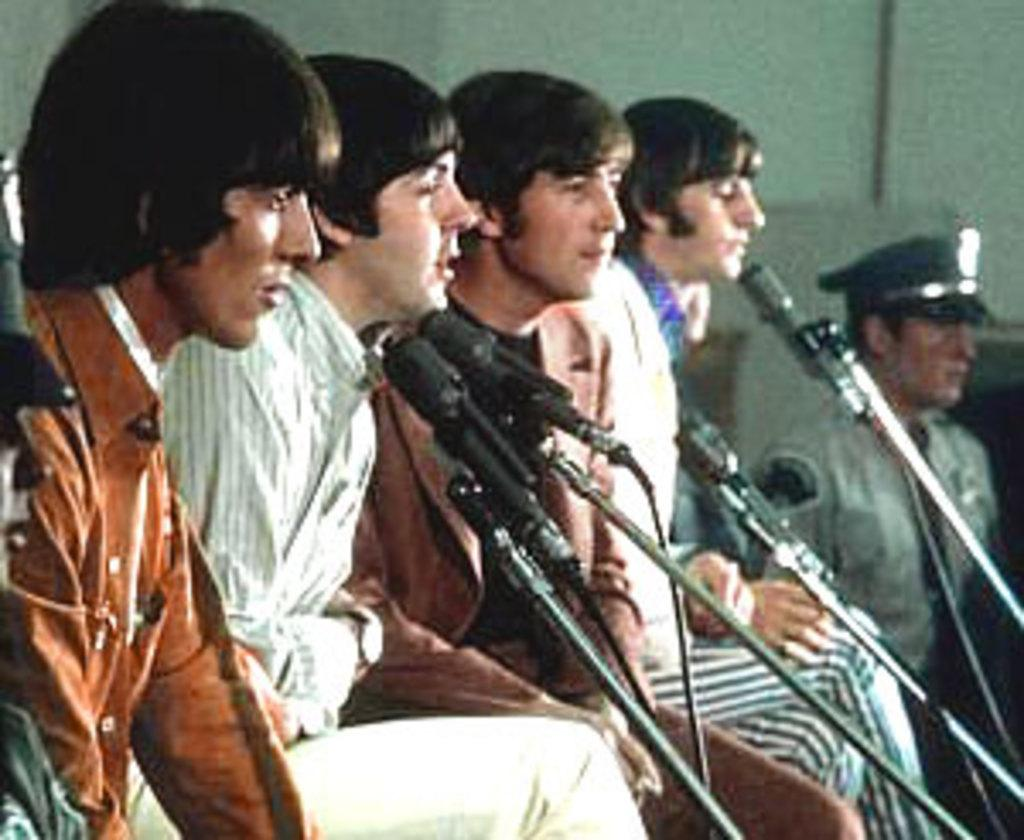What are the people in the image doing? There is a group of people sitting in the image. What objects can be seen on the right side of the image? There are microphones on the right side of the image. Can you describe the person standing in the image? There is a person standing at the back of the image. What is visible behind the group of people? There is a wall visible in the image. What type of ornament is hanging from the wall in the image? There is no ornament hanging from the wall in the image; only the wall is visible. How many dolls are sitting with the group of people in the image? There are no dolls present in the image; only people are visible. 